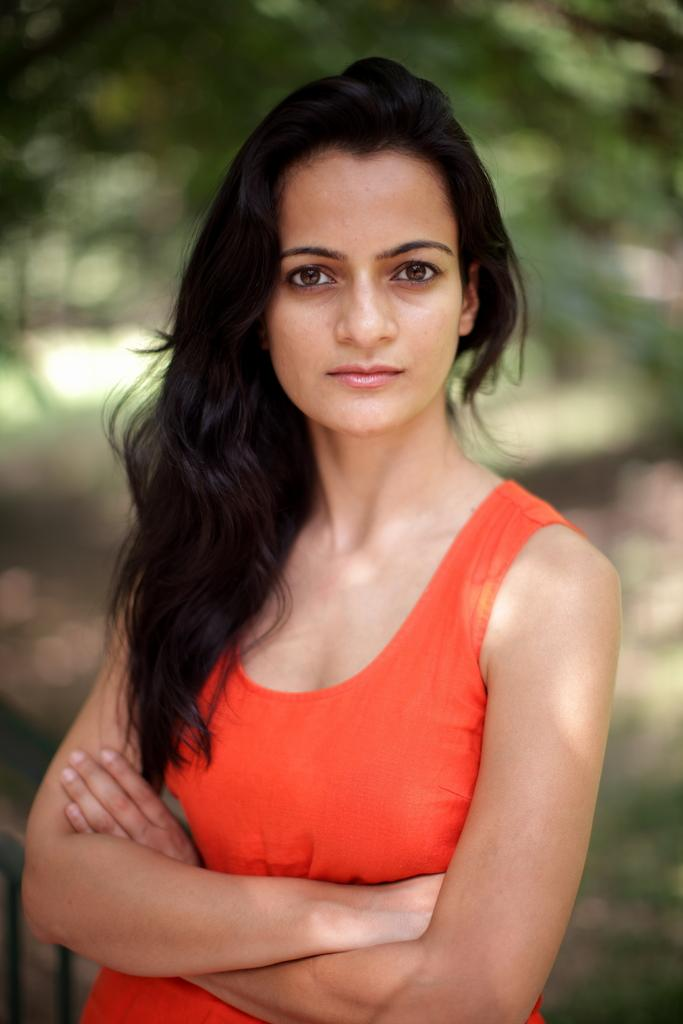Who is the main subject in the image? There is a woman in the image. What is the woman wearing? The woman is wearing an orange tank top. Can you describe the background of the image? The background of the image is blurred. What type of bulb is being used to support the woman in the image? There is no bulb or support system visible in the image; it features a woman wearing an orange tank top with a blurred background. 